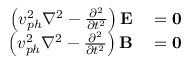Convert formula to latex. <formula><loc_0><loc_0><loc_500><loc_500>\begin{array} { r l } { \left ( v _ { p h } ^ { 2 } \nabla ^ { 2 } - { \frac { \partial ^ { 2 } } { \partial t ^ { 2 } } } \right ) E } & = 0 } \\ { \left ( v _ { p h } ^ { 2 } \nabla ^ { 2 } - { \frac { \partial ^ { 2 } } { \partial t ^ { 2 } } } \right ) B } & = 0 } \end{array}</formula> 